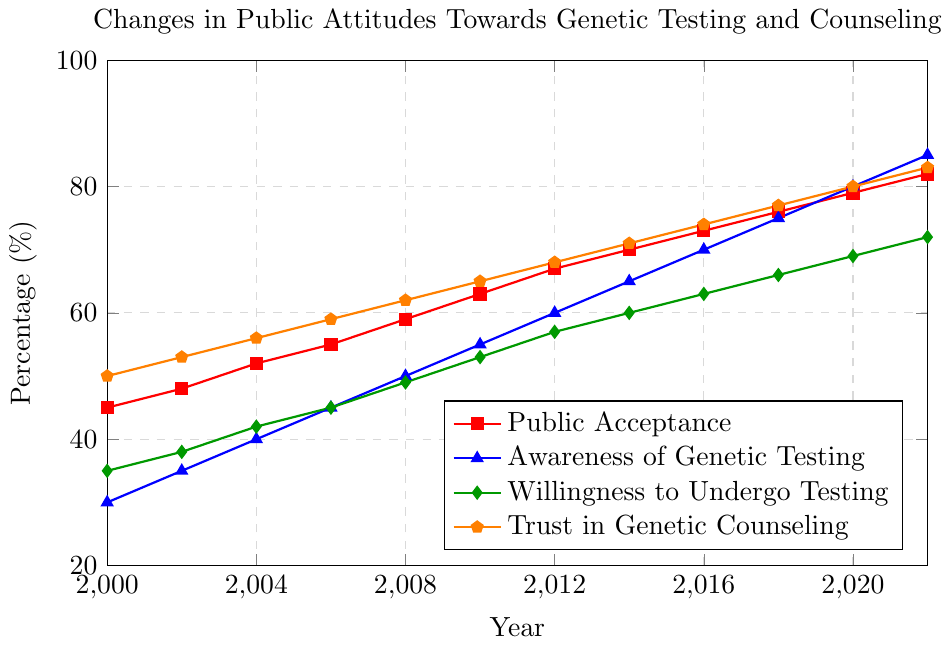Which year saw the highest public acceptance of genetic testing? To answer this, identify the highest value in the "Public Acceptance" line and note the corresponding year. The highest value, 82%, is in 2022.
Answer: 2022 How much did awareness of genetic testing increase between 2000 and 2022? Subtract the 2000 awareness percentage from the 2022 awareness percentage (85% - 30%).
Answer: 55% In what year did trust in genetic counseling surpass 70%? Look for the first year where the "Trust in Genetic Counseling" line reaches above 70%. This occurs in 2014.
Answer: 2014 What is the average public acceptance percentage from 2000 to 2022? Add up all the "Public Acceptance" values and divide by the number of data points. (45 + 48 + 52 + 55 + 59 + 63 + 67 + 70 + 73 + 76 + 79 + 82) / 12 = 64.67
Answer: 64.67 Which category had the steepest increase from 2000 to 2022? Compare the differences in percentages for each category from 2000 to 2022. Public Acceptance increased by 37%, Awareness of Genetic Testing by 55%, Willingness to Undergo Testing by 37%, and Trust in Genetic Counseling by 33%. Awareness of Genetic Testing had the steepest increase.
Answer: Awareness of Genetic Testing Was public acceptance higher than trust in genetic counseling at any point? Compare the "Public Acceptance" and "Trust in Genetic Counseling" lines for all years. Trust in Genetic Counseling is always higher than Public Acceptance.
Answer: No How did willingness to undergo testing change between 2006 and 2012? Find the values for the willingness to undergo testing in 2006 and 2012 and subtract the earlier value from the later one (57% - 45%).
Answer: 12% Compare the increase rates of public acceptance and awareness of genetic testing between 2008 and 2020. Calculate the increases for both categories between 2008 and 2020. Public Acceptance increased from 59% to 79% (20%), while Awareness of Genetic Testing increased from 50% to 80% (30%). Awareness of Genetic Testing had a higher increase rate.
Answer: Awareness of Genetic Testing Which year had the smallest change in willingness to undergo testing compared to the previous year? Calculate the yearly differences for willingness to undergo testing and identify the smallest value. The smallest change was between 2010 (53%) and 2012 (57%), a difference of 4%.
Answer: 2010 to 2012 